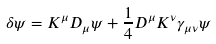<formula> <loc_0><loc_0><loc_500><loc_500>\delta \psi = K ^ { \mu } D _ { \mu } \psi + \frac { 1 } { 4 } D ^ { \mu } K ^ { \nu } \gamma _ { \mu \nu } \psi</formula> 